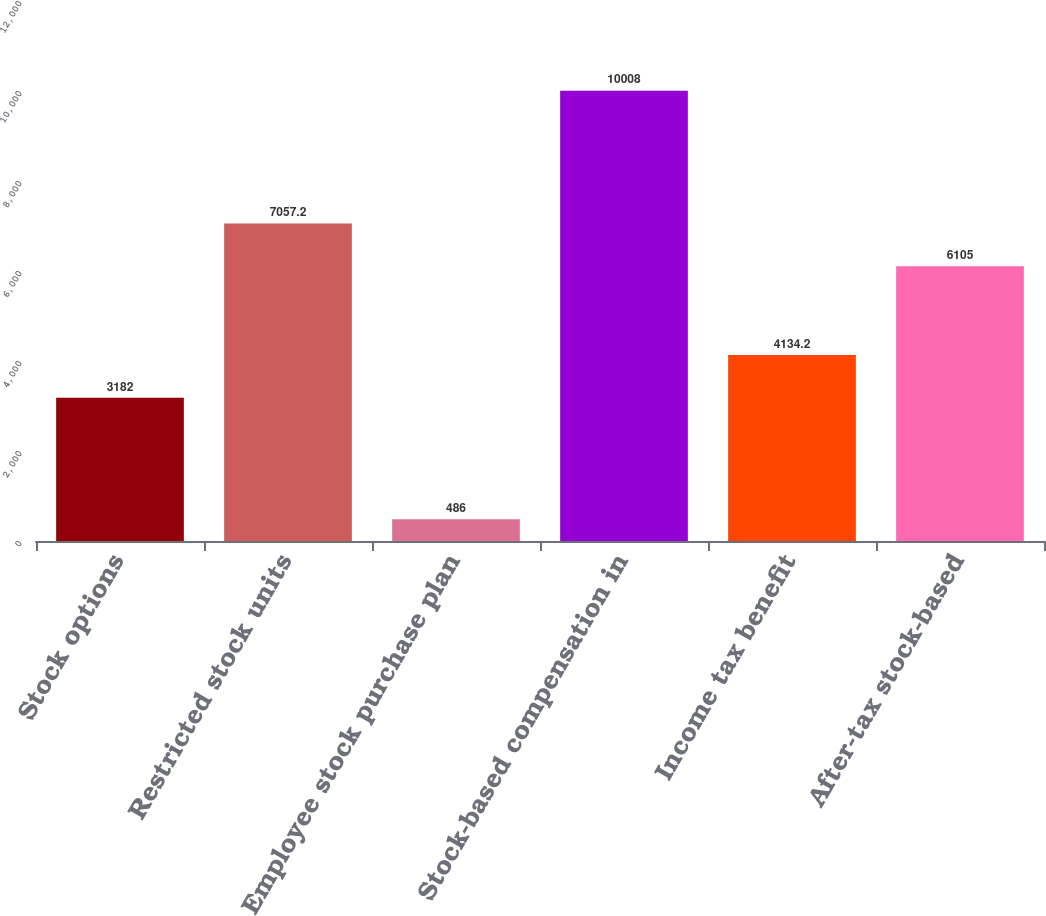<chart> <loc_0><loc_0><loc_500><loc_500><bar_chart><fcel>Stock options<fcel>Restricted stock units<fcel>Employee stock purchase plan<fcel>Stock-based compensation in<fcel>Income tax benefit<fcel>After-tax stock-based<nl><fcel>3182<fcel>7057.2<fcel>486<fcel>10008<fcel>4134.2<fcel>6105<nl></chart> 